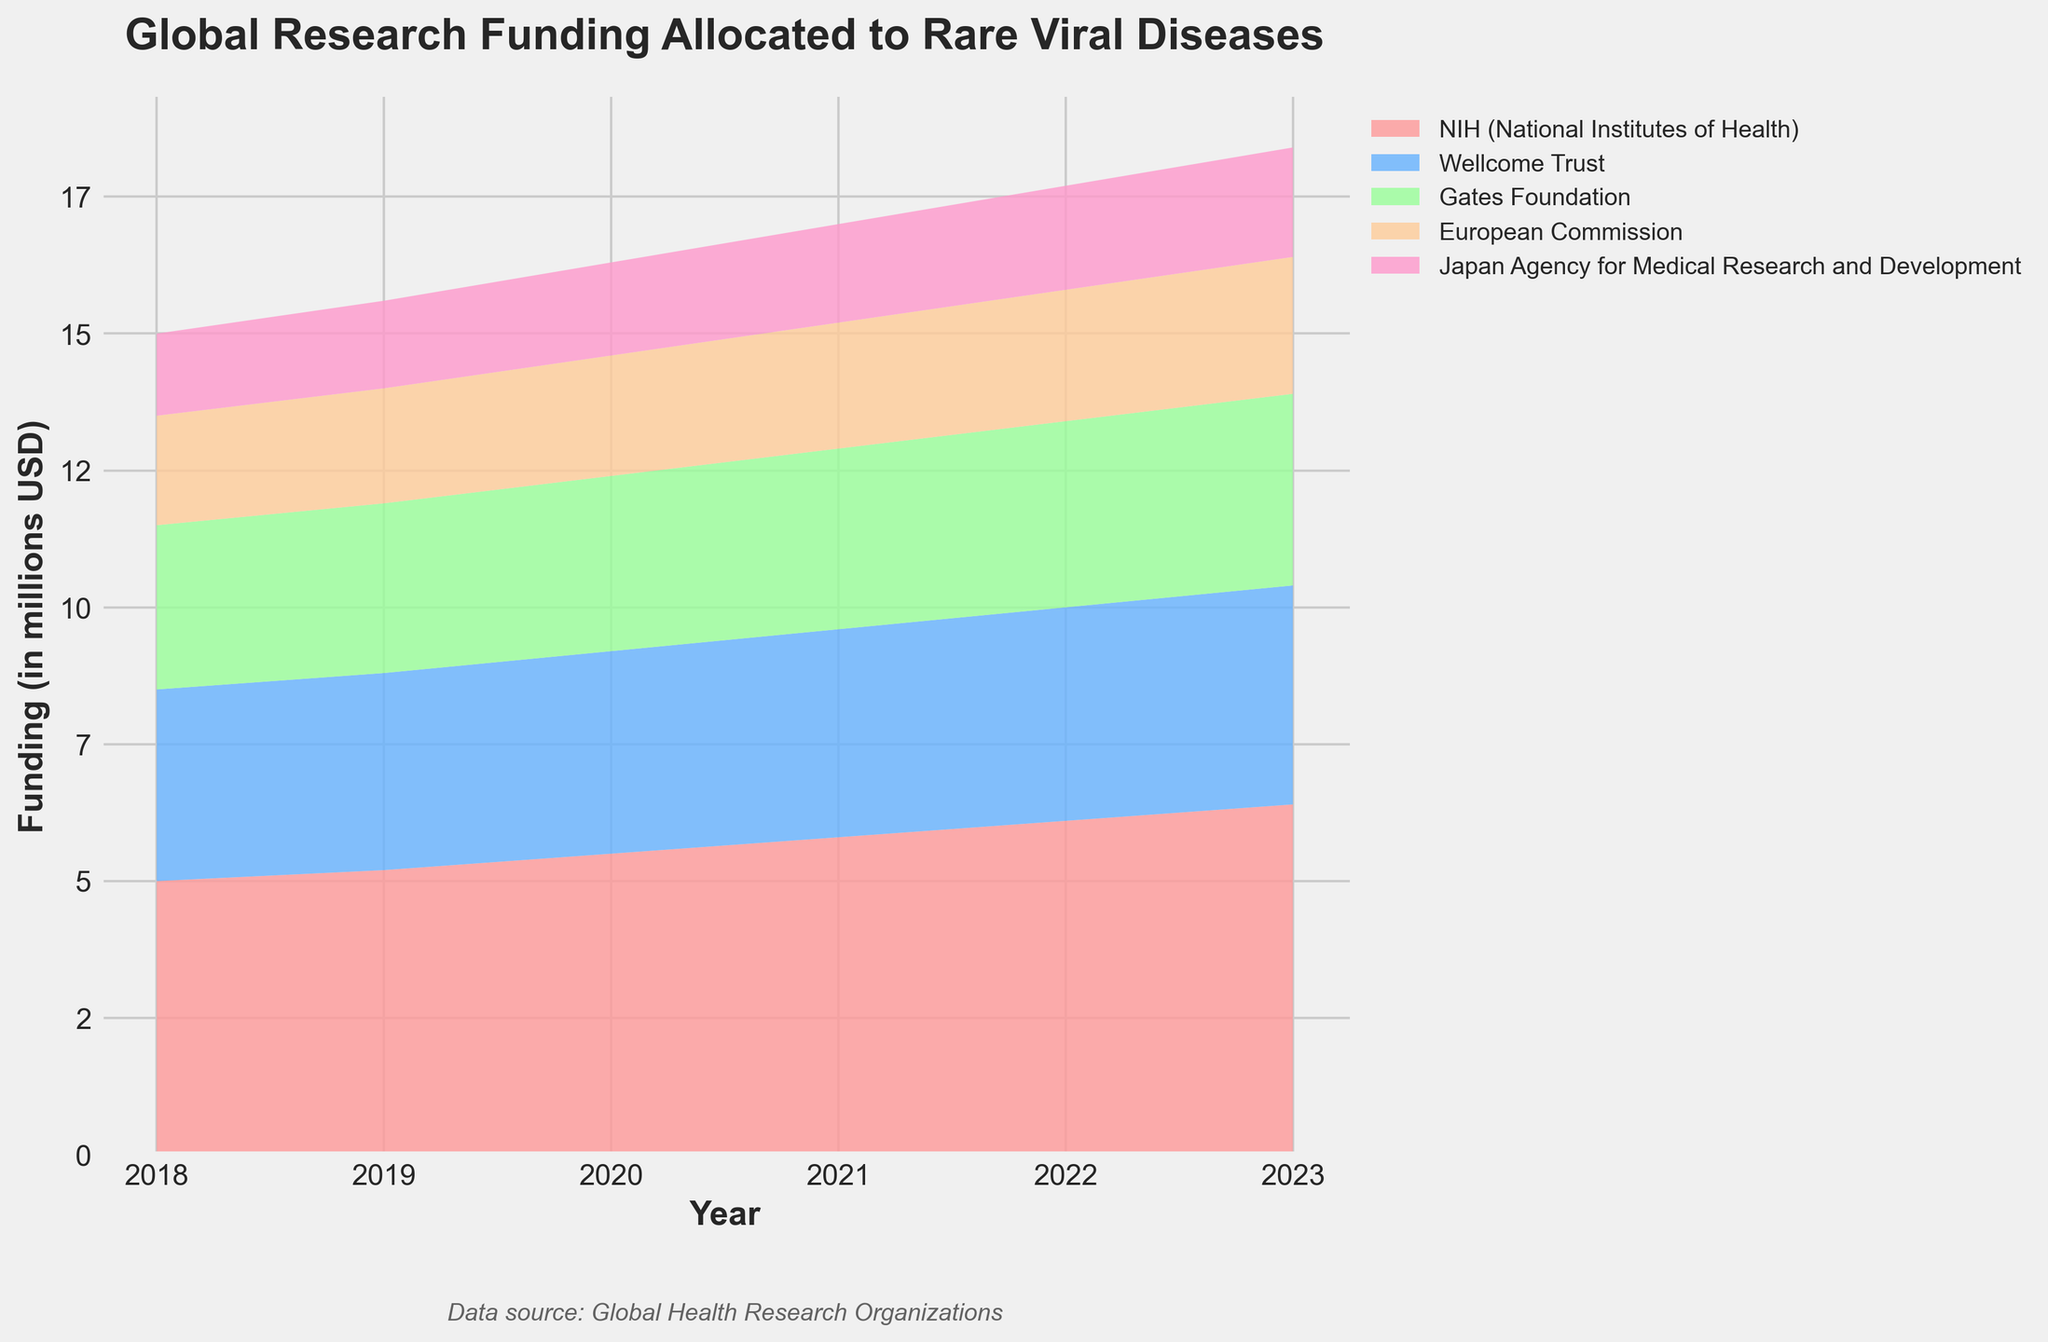What is the title of the chart? The title of the chart is displayed prominently at the top and reads "Global Research Funding Allocated to Rare Viral Diseases."
Answer: Global Research Funding Allocated to Rare Viral Diseases Which organization had the highest funding in 2023? The area representing the NIH (National Institutes of Health) is the largest at the 2023 mark on the x-axis, indicating it had the highest funding.
Answer: NIH How did the funding from Wellcome Trust change from 2019 to 2021? By looking at the area for Wellcome Trust between 2019 and 2021, the funding increased from 3.6 million USD in 2019 to 3.8 million USD in 2021.
Answer: Increased from 3.6 million USD to 3.8 million USD What is the total research funding allocated to rare viral diseases in 2020? To find the total funding for 2020, sum the values for all organizations: 5.5M (NIH) + 3.7M (Wellcome Trust) + 3.2M (Gates Foundation) + 2.2M (European Commission) + 1.7M (Japan AMED) = 16.3 million USD.
Answer: 16.3 million USD Which organization showed the least increase in funding from 2022 to 2023? The Japan Agency for Medical Research and Development's funding increased from 1.9 million USD to 2.0 million USD, a 0.1 million increase, which is smaller compared to other organizations.
Answer: Japan AMED How many organizations are displayed on the chart? Count the different colored areas in the chart representing the funding from various organizations. There are five distinct areas.
Answer: 5 organizations When did the Gates Foundation funding surpass 3.0 million USD? Look for the point on the x-axis where the cumulative area for Gates Foundation exceeds 3.0 million USD. This occurs in 2020.
Answer: 2020 In which year did the combined funding from European Commission and Japan AMED first exceed 4 million USD? Add the funding from European Commission and Japan AMED for each year until their sum exceeds 4 million USD: It happens in 2021 (2.3M + 1.8M = 4.1 million USD).
Answer: 2021 Which organization had a consistent annual increase in funding throughout the 6-year period? By examining the areas, the NIH (National Institutes of Health) continually grows in size yearly without any decrease.
Answer: NIH How much did the total combined funding increase from 2018 to 2023? Calculate the total funding for both years and find the difference: 2018 (5M + 3.5M + 3M + 2M + 1.5M = 15M) and 2023 (6.4M + 4M + 3.5M + 2.5M + 2M = 18.4M); The increase is 18.4M - 15M = 3.4 million USD.
Answer: 3.4 million USD 